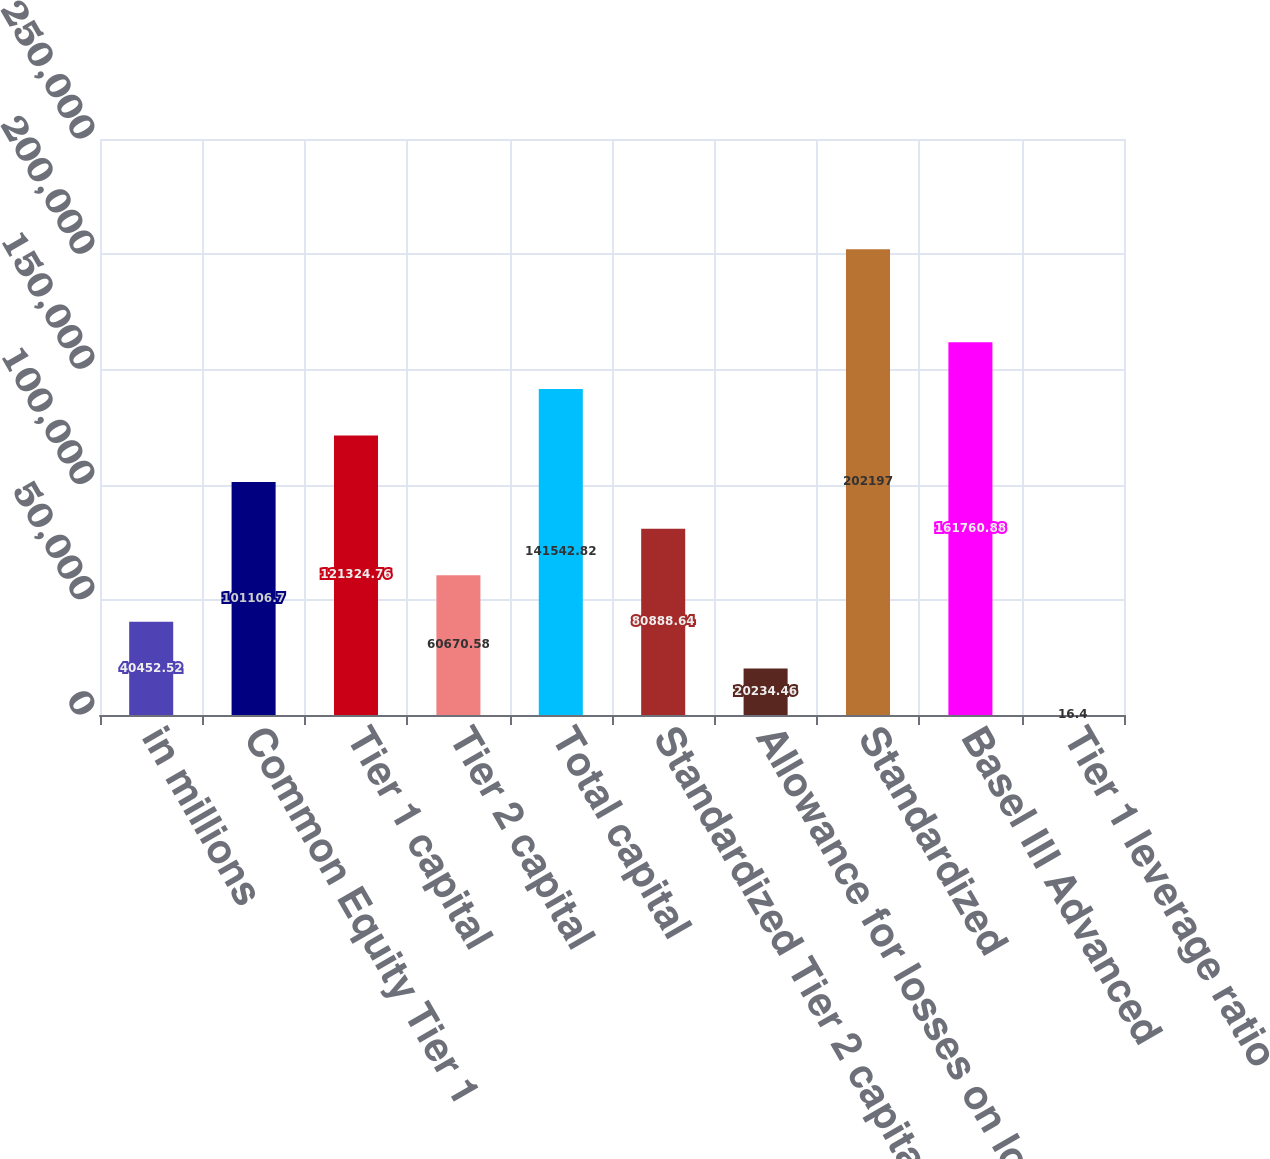<chart> <loc_0><loc_0><loc_500><loc_500><bar_chart><fcel>in millions<fcel>Common Equity Tier 1<fcel>Tier 1 capital<fcel>Tier 2 capital<fcel>Total capital<fcel>Standardized Tier 2 capital<fcel>Allowance for losses on loans<fcel>Standardized<fcel>Basel III Advanced<fcel>Tier 1 leverage ratio<nl><fcel>40452.5<fcel>101107<fcel>121325<fcel>60670.6<fcel>141543<fcel>80888.6<fcel>20234.5<fcel>202197<fcel>161761<fcel>16.4<nl></chart> 